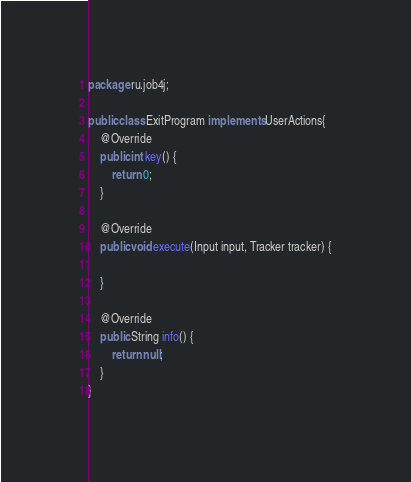<code> <loc_0><loc_0><loc_500><loc_500><_Java_>package ru.job4j;

public class ExitProgram implements UserActions{
    @Override
    public int key() {
        return 0;
    }

    @Override
    public void execute(Input input, Tracker tracker) {

    }

    @Override
    public String info() {
        return null;
    }
}
</code> 